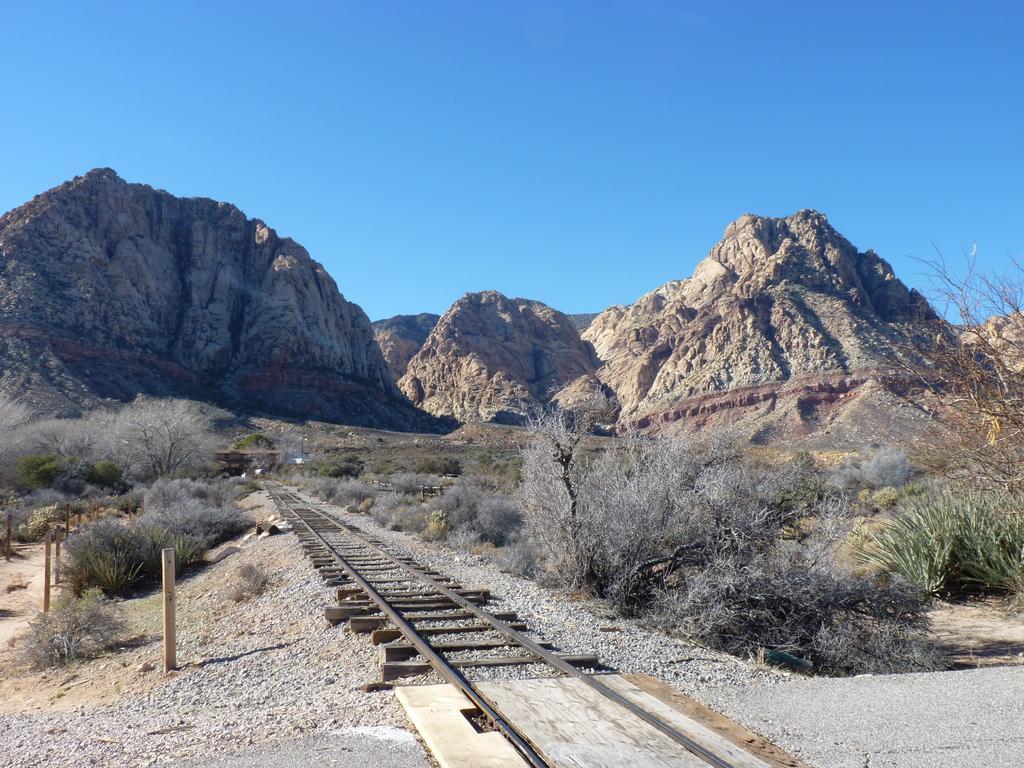Please provide a concise description of this image. We can see track,plants,dried trees and wooden poles. In the background we can see hills and sky in blue color. 